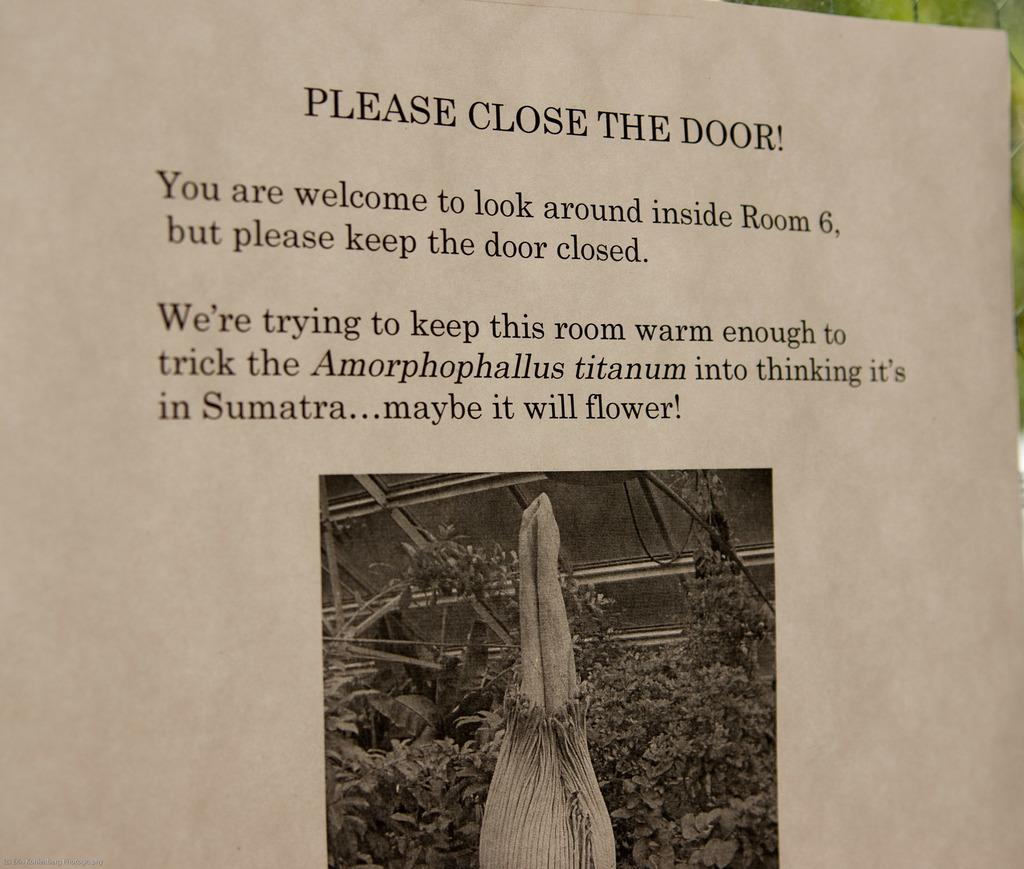What type of visual is the image? The image is a poster. What are some of the main elements depicted on the poster? There are rods, plants, and objects depicted on the poster. Is there any text present on the poster? Yes, there is text present on the poster. How many lizards can be seen climbing the rods on the poster? There are no lizards depicted on the poster; it only features rods, plants, objects, and text. 